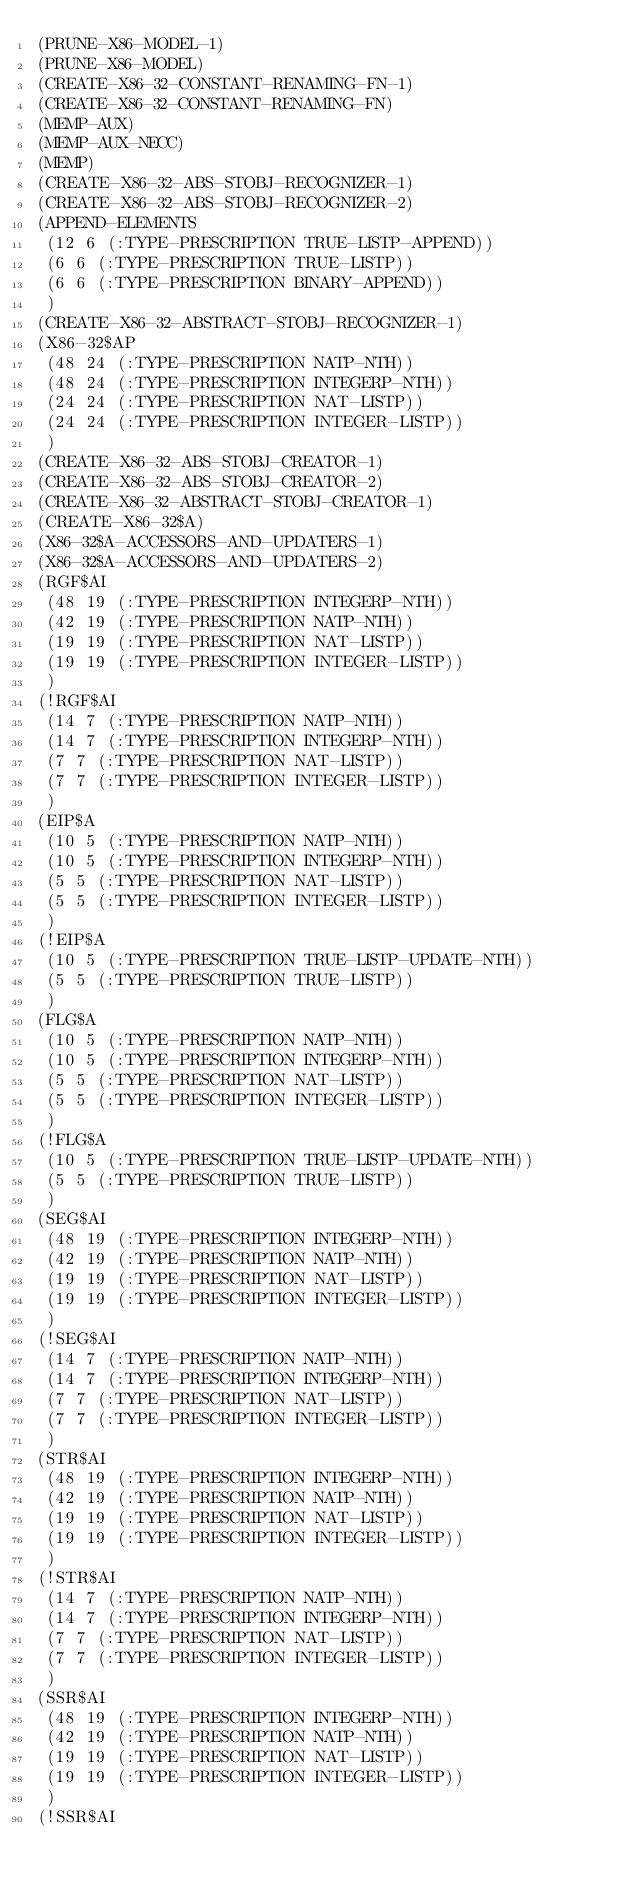Convert code to text. <code><loc_0><loc_0><loc_500><loc_500><_Lisp_>(PRUNE-X86-MODEL-1)
(PRUNE-X86-MODEL)
(CREATE-X86-32-CONSTANT-RENAMING-FN-1)
(CREATE-X86-32-CONSTANT-RENAMING-FN)
(MEMP-AUX)
(MEMP-AUX-NECC)
(MEMP)
(CREATE-X86-32-ABS-STOBJ-RECOGNIZER-1)
(CREATE-X86-32-ABS-STOBJ-RECOGNIZER-2)
(APPEND-ELEMENTS
 (12 6 (:TYPE-PRESCRIPTION TRUE-LISTP-APPEND))
 (6 6 (:TYPE-PRESCRIPTION TRUE-LISTP))
 (6 6 (:TYPE-PRESCRIPTION BINARY-APPEND))
 )
(CREATE-X86-32-ABSTRACT-STOBJ-RECOGNIZER-1)
(X86-32$AP
 (48 24 (:TYPE-PRESCRIPTION NATP-NTH))
 (48 24 (:TYPE-PRESCRIPTION INTEGERP-NTH))
 (24 24 (:TYPE-PRESCRIPTION NAT-LISTP))
 (24 24 (:TYPE-PRESCRIPTION INTEGER-LISTP))
 )
(CREATE-X86-32-ABS-STOBJ-CREATOR-1)
(CREATE-X86-32-ABS-STOBJ-CREATOR-2)
(CREATE-X86-32-ABSTRACT-STOBJ-CREATOR-1)
(CREATE-X86-32$A)
(X86-32$A-ACCESSORS-AND-UPDATERS-1)
(X86-32$A-ACCESSORS-AND-UPDATERS-2)
(RGF$AI
 (48 19 (:TYPE-PRESCRIPTION INTEGERP-NTH))
 (42 19 (:TYPE-PRESCRIPTION NATP-NTH))
 (19 19 (:TYPE-PRESCRIPTION NAT-LISTP))
 (19 19 (:TYPE-PRESCRIPTION INTEGER-LISTP))
 )
(!RGF$AI
 (14 7 (:TYPE-PRESCRIPTION NATP-NTH))
 (14 7 (:TYPE-PRESCRIPTION INTEGERP-NTH))
 (7 7 (:TYPE-PRESCRIPTION NAT-LISTP))
 (7 7 (:TYPE-PRESCRIPTION INTEGER-LISTP))
 )
(EIP$A
 (10 5 (:TYPE-PRESCRIPTION NATP-NTH))
 (10 5 (:TYPE-PRESCRIPTION INTEGERP-NTH))
 (5 5 (:TYPE-PRESCRIPTION NAT-LISTP))
 (5 5 (:TYPE-PRESCRIPTION INTEGER-LISTP))
 )
(!EIP$A
 (10 5 (:TYPE-PRESCRIPTION TRUE-LISTP-UPDATE-NTH))
 (5 5 (:TYPE-PRESCRIPTION TRUE-LISTP))
 )
(FLG$A
 (10 5 (:TYPE-PRESCRIPTION NATP-NTH))
 (10 5 (:TYPE-PRESCRIPTION INTEGERP-NTH))
 (5 5 (:TYPE-PRESCRIPTION NAT-LISTP))
 (5 5 (:TYPE-PRESCRIPTION INTEGER-LISTP))
 )
(!FLG$A
 (10 5 (:TYPE-PRESCRIPTION TRUE-LISTP-UPDATE-NTH))
 (5 5 (:TYPE-PRESCRIPTION TRUE-LISTP))
 )
(SEG$AI
 (48 19 (:TYPE-PRESCRIPTION INTEGERP-NTH))
 (42 19 (:TYPE-PRESCRIPTION NATP-NTH))
 (19 19 (:TYPE-PRESCRIPTION NAT-LISTP))
 (19 19 (:TYPE-PRESCRIPTION INTEGER-LISTP))
 )
(!SEG$AI
 (14 7 (:TYPE-PRESCRIPTION NATP-NTH))
 (14 7 (:TYPE-PRESCRIPTION INTEGERP-NTH))
 (7 7 (:TYPE-PRESCRIPTION NAT-LISTP))
 (7 7 (:TYPE-PRESCRIPTION INTEGER-LISTP))
 )
(STR$AI
 (48 19 (:TYPE-PRESCRIPTION INTEGERP-NTH))
 (42 19 (:TYPE-PRESCRIPTION NATP-NTH))
 (19 19 (:TYPE-PRESCRIPTION NAT-LISTP))
 (19 19 (:TYPE-PRESCRIPTION INTEGER-LISTP))
 )
(!STR$AI
 (14 7 (:TYPE-PRESCRIPTION NATP-NTH))
 (14 7 (:TYPE-PRESCRIPTION INTEGERP-NTH))
 (7 7 (:TYPE-PRESCRIPTION NAT-LISTP))
 (7 7 (:TYPE-PRESCRIPTION INTEGER-LISTP))
 )
(SSR$AI
 (48 19 (:TYPE-PRESCRIPTION INTEGERP-NTH))
 (42 19 (:TYPE-PRESCRIPTION NATP-NTH))
 (19 19 (:TYPE-PRESCRIPTION NAT-LISTP))
 (19 19 (:TYPE-PRESCRIPTION INTEGER-LISTP))
 )
(!SSR$AI</code> 